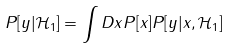Convert formula to latex. <formula><loc_0><loc_0><loc_500><loc_500>P [ y | \mathcal { H } _ { 1 } ] = \int D x P [ x ] P [ y | x , \mathcal { H } _ { 1 } ]</formula> 